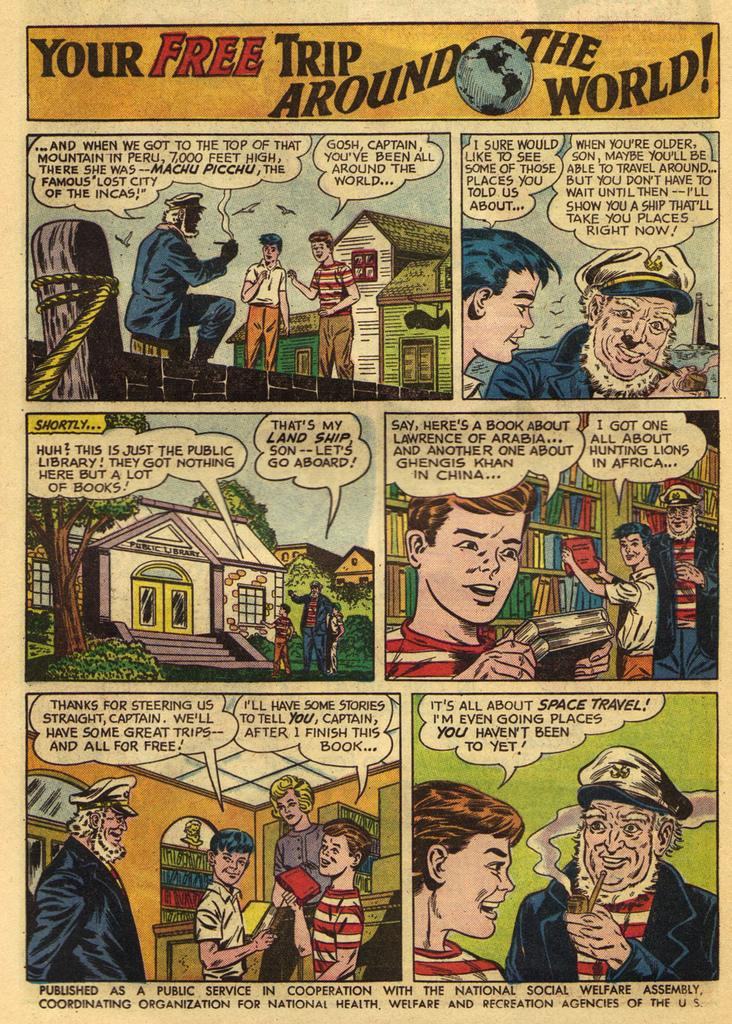Provide a one-sentence caption for the provided image. A comic book story is tantalizingly titled Your Free Trip Around the World. 